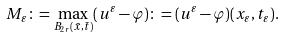Convert formula to latex. <formula><loc_0><loc_0><loc_500><loc_500>M _ { \varepsilon } \colon = \max _ { B _ { 2 r } ( \bar { x } , \bar { t } ) } ( u ^ { \varepsilon } - \varphi ) \colon = ( u ^ { \varepsilon } - \varphi ) ( x _ { \varepsilon } , t _ { \varepsilon } ) .</formula> 